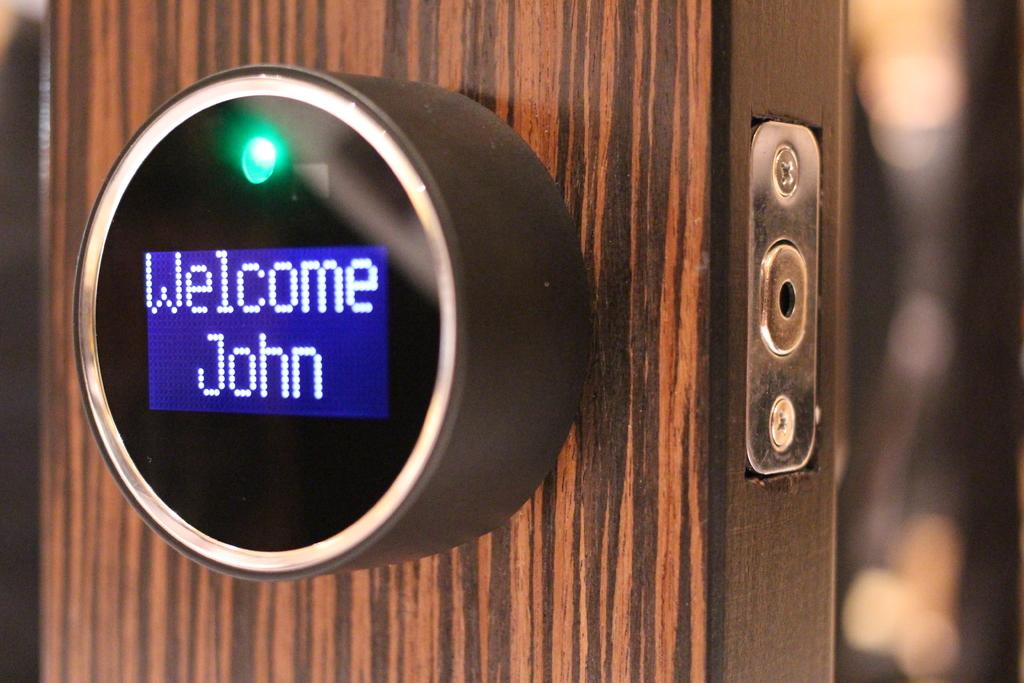<image>
Share a concise interpretation of the image provided. a round smart device on a door reading Welcome John 